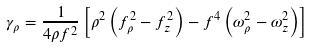<formula> <loc_0><loc_0><loc_500><loc_500>\gamma _ { \rho } = \frac { 1 } { 4 \rho f ^ { 2 } } \left [ \rho ^ { 2 } \left ( f _ { \rho } ^ { 2 } - f _ { z } ^ { 2 } \right ) - f ^ { 4 } \left ( \omega _ { \rho } ^ { 2 } - \omega _ { z } ^ { 2 } \right ) \right ]</formula> 